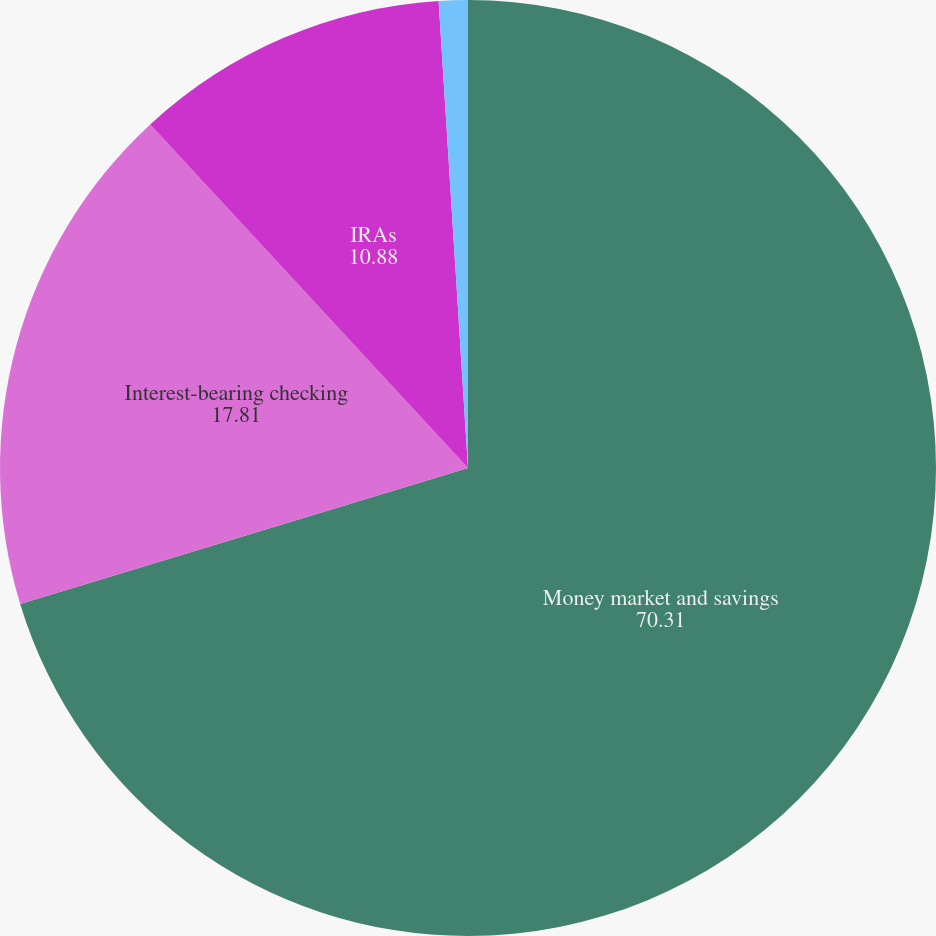<chart> <loc_0><loc_0><loc_500><loc_500><pie_chart><fcel>Money market and savings<fcel>Interest-bearing checking<fcel>IRAs<fcel>Certificates of deposit<nl><fcel>70.31%<fcel>17.81%<fcel>10.88%<fcel>1.0%<nl></chart> 